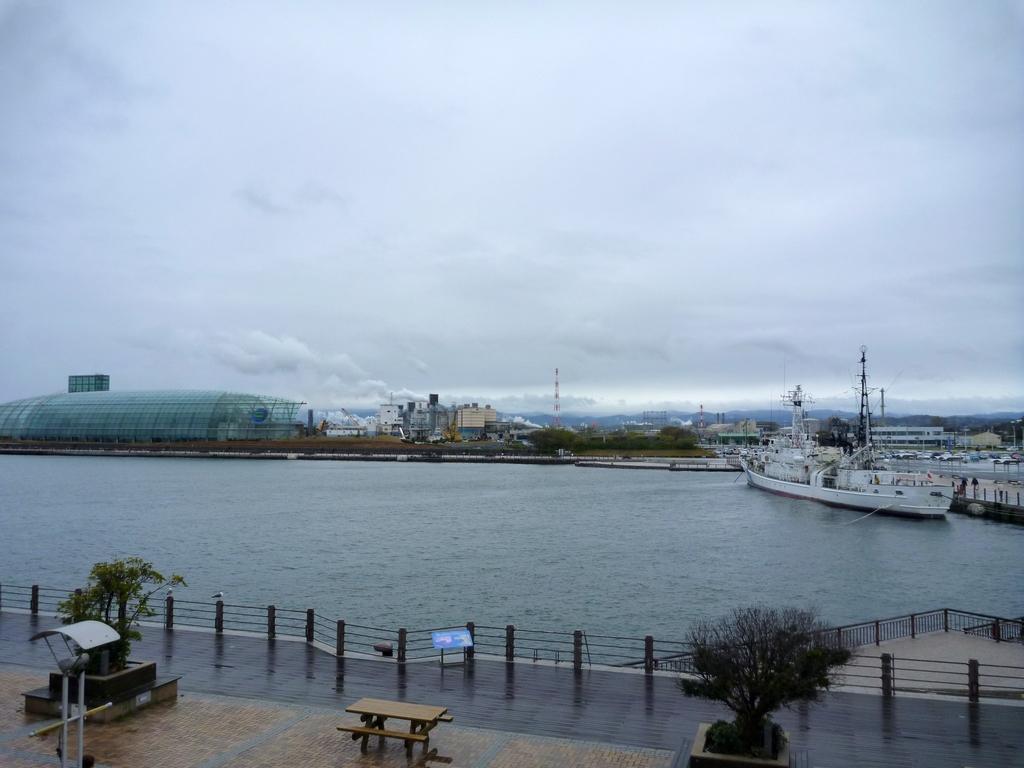How would you summarize this image in a sentence or two? In this image, we can see trees, buildings and there are ships on the water and we can see railings, a bench and there are plants, towers and a stand. At the top, there are clouds in the sky and at the bottom, there is a floor. 